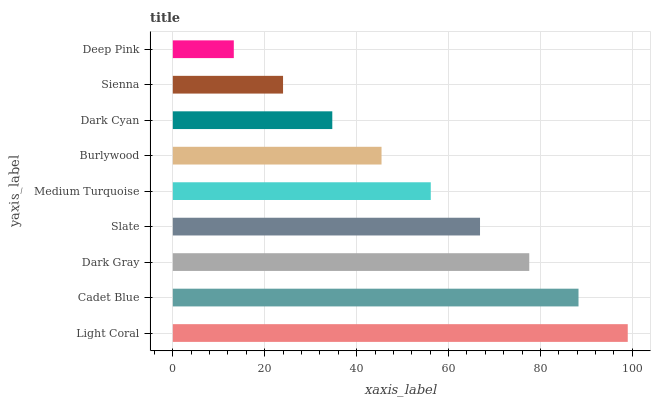Is Deep Pink the minimum?
Answer yes or no. Yes. Is Light Coral the maximum?
Answer yes or no. Yes. Is Cadet Blue the minimum?
Answer yes or no. No. Is Cadet Blue the maximum?
Answer yes or no. No. Is Light Coral greater than Cadet Blue?
Answer yes or no. Yes. Is Cadet Blue less than Light Coral?
Answer yes or no. Yes. Is Cadet Blue greater than Light Coral?
Answer yes or no. No. Is Light Coral less than Cadet Blue?
Answer yes or no. No. Is Medium Turquoise the high median?
Answer yes or no. Yes. Is Medium Turquoise the low median?
Answer yes or no. Yes. Is Dark Gray the high median?
Answer yes or no. No. Is Cadet Blue the low median?
Answer yes or no. No. 